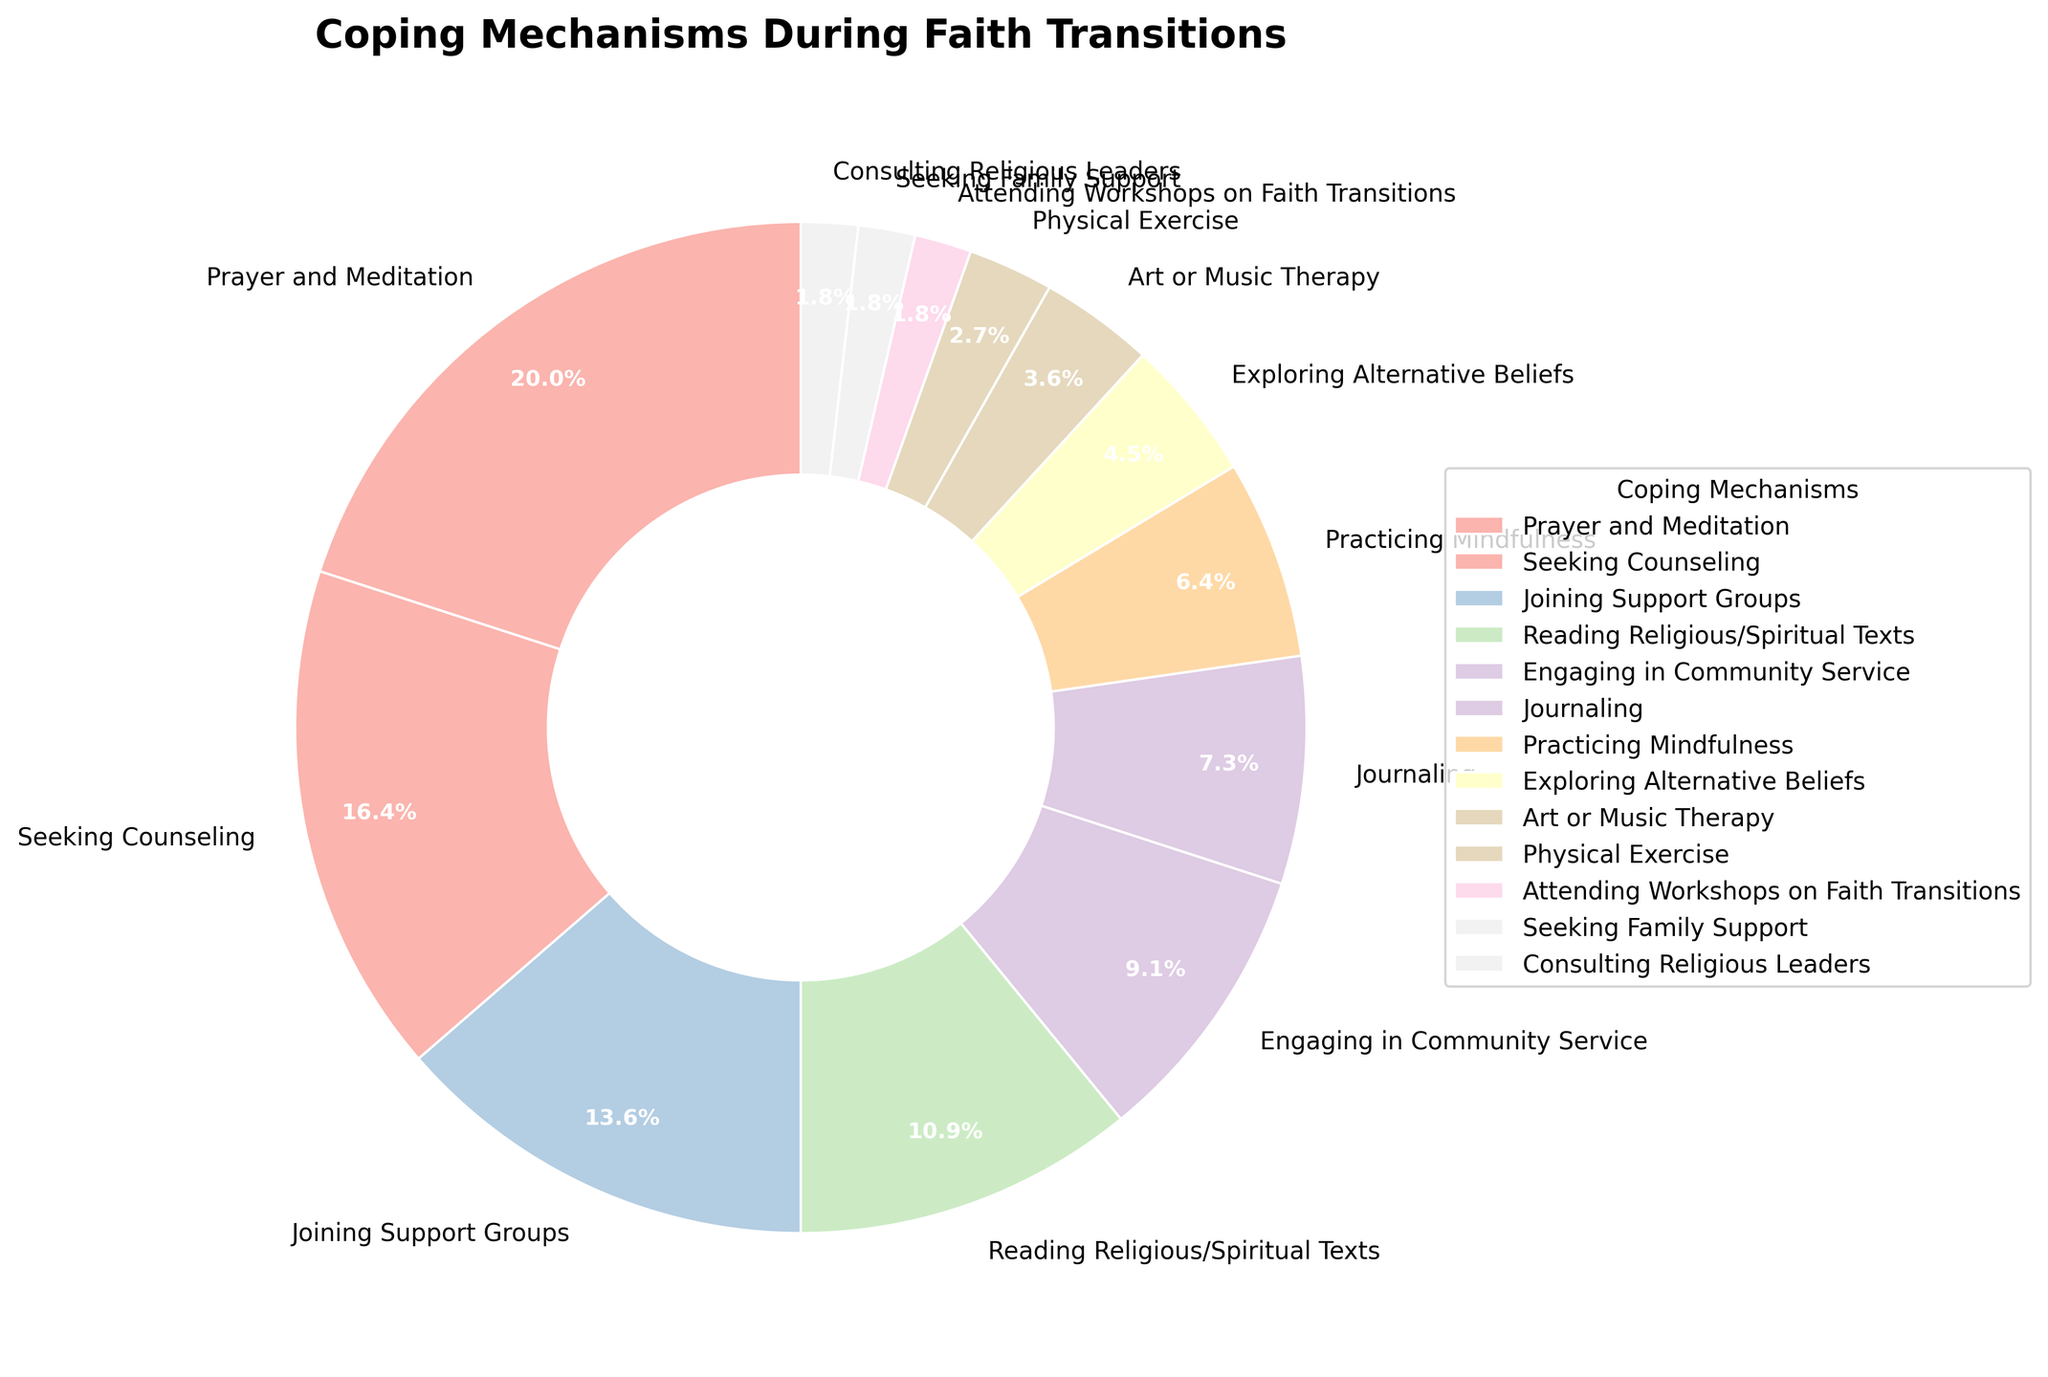What is the most popular coping mechanism during faith transitions? By looking at the pie chart, the largest segment represents the most popular coping mechanism. The segment for "Prayer and Meditation" is the largest with 22% labeled.
Answer: Prayer and Meditation How much more popular is Seeking Counseling compared to Physical Exercise? To find the difference, we compare their percentages. "Seeking Counseling" is at 18% and "Physical Exercise" is at 3%. Subtracting these gives 18 - 3.
Answer: 15% What percentage of individuals use both Engaging in Community Service and Reading Religious/Spiritual Texts as their coping mechanisms? To find the sum, add the percentages of "Engaging in Community Service" (10%) and "Reading Religious/Spiritual Texts" (12%). So, 10 + 12 = 22.
Answer: 22% Which three coping mechanisms are the least popular? By referring to the pie chart, the three smallest segments are "Attending Workshops on Faith Transitions," "Seeking Family Support," and "Consulting Religious Leaders", each with 2%.
Answer: Attending Workshops on Faith Transitions, Seeking Family Support, Consulting Religious Leaders How does the percentage of individuals practicing mindfulness compare to those journaling? "Practicing Mindfulness" represents 7% while "Journaling" is at 8%. Therefore, practicing mindfulness is 1% less than journaling.
Answer: 1% less What is the combined percentage of individuals who use Art or Music Therapy and Exploring Alternative Beliefs? Add the percentages of "Art or Music Therapy" (4%) and "Exploring Alternative Beliefs" (5%). So, 4 + 5 = 9.
Answer: 9% Which coping mechanism has a percentage closest to 10%, and identify it? The pie chart shows "Engaging in Community Service" at exactly 10%.
Answer: Engaging in Community Service What is the total percentage of individuals who use the three most popular coping mechanisms? The three most popular are "Prayer and Meditation" (22%), "Seeking Counseling" (18%), and "Joining Support Groups" (15%). Adding these gives 22 + 18 + 15 = 55.
Answer: 55% How many more individuals use Prayer and Meditation compared to Consulting Religious Leaders? "Prayer and Meditation" has 22%, and "Consulting Religious Leaders" is at 2%. To find the difference, subtract 2 from 22 which means 22 - 2.
Answer: 20% If we combine the percentages of those who read religious/spiritual texts and join support groups, how does it compare to those who seek counseling? "Reading Religious/Spiritual Texts" is at 12% and "Joining Support Groups" is 15%. Their sum is 12 + 15 = 27%. This is compared to "Seeking Counseling" at 18%. So, 27 - 18 = 9%.
Answer: 9% more 